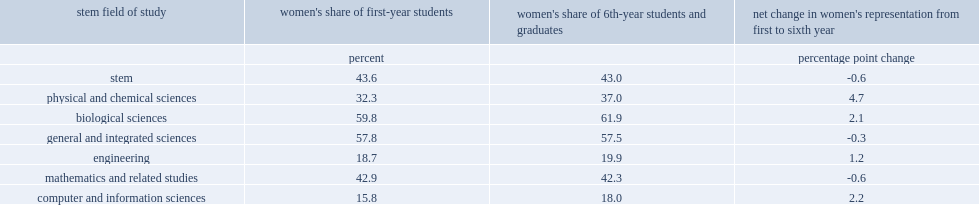How many percentage points did women make up first-year students in physical and chemical sciences? 32.3. How many percentage points did women make up sixth-year students and graduates in physical and chemical sciences? 37.0. How many percentage points did women make up first-year students in computer and information sciences? 15.8. How many percentage points did women make up sixth-year students and graduates in computer and information sciences? 18.0. 